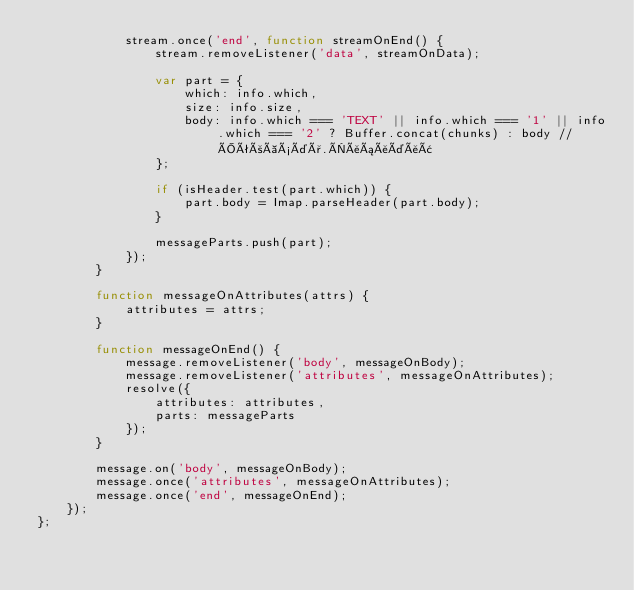<code> <loc_0><loc_0><loc_500><loc_500><_JavaScript_>            stream.once('end', function streamOnEnd() {
                stream.removeListener('data', streamOnData);

                var part = {
                    which: info.which,
                    size: info.size,
                    body: info.which === 'TEXT' || info.which === '1' || info.which === '2' ? Buffer.concat(chunks) : body // Îêòàýäð.Ëåáåäåâ
                };

                if (isHeader.test(part.which)) {
                    part.body = Imap.parseHeader(part.body);
                }

                messageParts.push(part);
            });
        }

        function messageOnAttributes(attrs) {
            attributes = attrs;
        }

        function messageOnEnd() {
            message.removeListener('body', messageOnBody);
            message.removeListener('attributes', messageOnAttributes);
            resolve({
                attributes: attributes,
                parts: messageParts
            });
        }

        message.on('body', messageOnBody);
        message.once('attributes', messageOnAttributes);
        message.once('end', messageOnEnd);
    });
};
</code> 